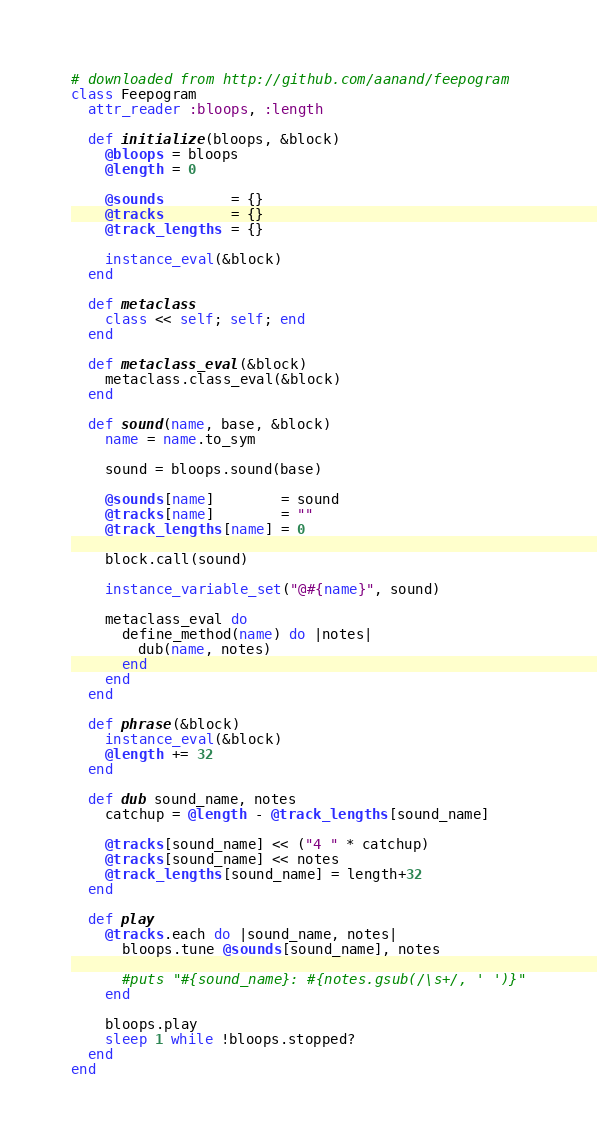Convert code to text. <code><loc_0><loc_0><loc_500><loc_500><_Ruby_># downloaded from http://github.com/aanand/feepogram
class Feepogram
  attr_reader :bloops, :length

  def initialize(bloops, &block)
    @bloops = bloops
    @length = 0

    @sounds        = {}
    @tracks        = {}
    @track_lengths = {}

    instance_eval(&block)
  end

  def metaclass
    class << self; self; end
  end

  def metaclass_eval(&block)
    metaclass.class_eval(&block)
  end

  def sound(name, base, &block)
    name = name.to_sym

    sound = bloops.sound(base)

    @sounds[name]        = sound
    @tracks[name]        = ""
    @track_lengths[name] = 0

    block.call(sound)

    instance_variable_set("@#{name}", sound)

    metaclass_eval do
      define_method(name) do |notes|
        dub(name, notes)
      end
    end
  end

  def phrase(&block)
    instance_eval(&block)
    @length += 32
  end

  def dub sound_name, notes
    catchup = @length - @track_lengths[sound_name]

    @tracks[sound_name] << ("4 " * catchup)
    @tracks[sound_name] << notes
    @track_lengths[sound_name] = length+32
  end

  def play
    @tracks.each do |sound_name, notes|
      bloops.tune @sounds[sound_name], notes

      #puts "#{sound_name}: #{notes.gsub(/\s+/, ' ')}"
    end

    bloops.play
    sleep 1 while !bloops.stopped?
  end
end
</code> 